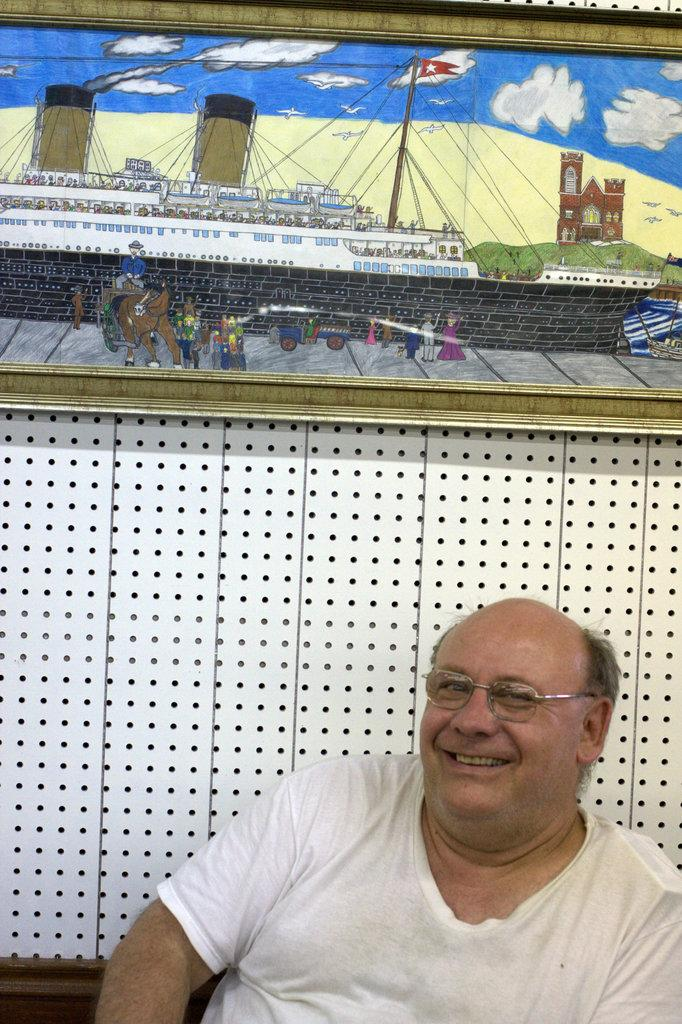Who is present in the image? There is a man in the image. What is the man wearing? The man is wearing a white T-shirt. What can be seen in the background of the image? There is a wall in the background of the image. What is on the wall? There is a painting on the wall. What type of coal is being used to fuel the man's interest in the painting? There is no coal or reference to fueling interest in the image. The man is simply standing in front of a wall with a painting on it. 